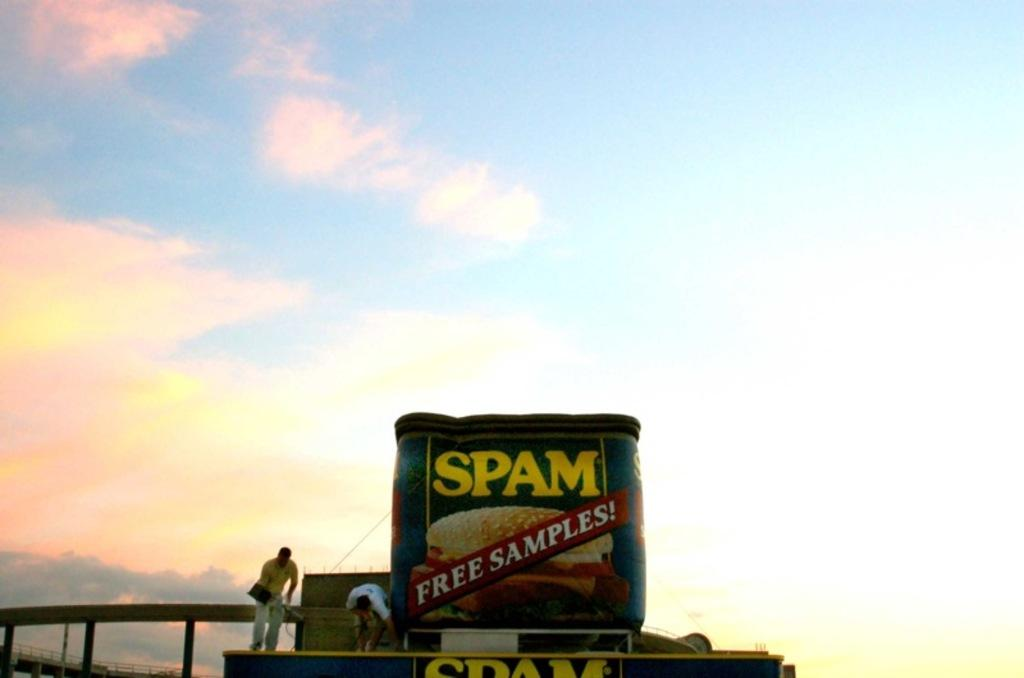<image>
Create a compact narrative representing the image presented. a giant display of SPAM is being erected 